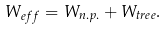<formula> <loc_0><loc_0><loc_500><loc_500>W _ { e f f } = W _ { n . p . } + W _ { t r e e } .</formula> 